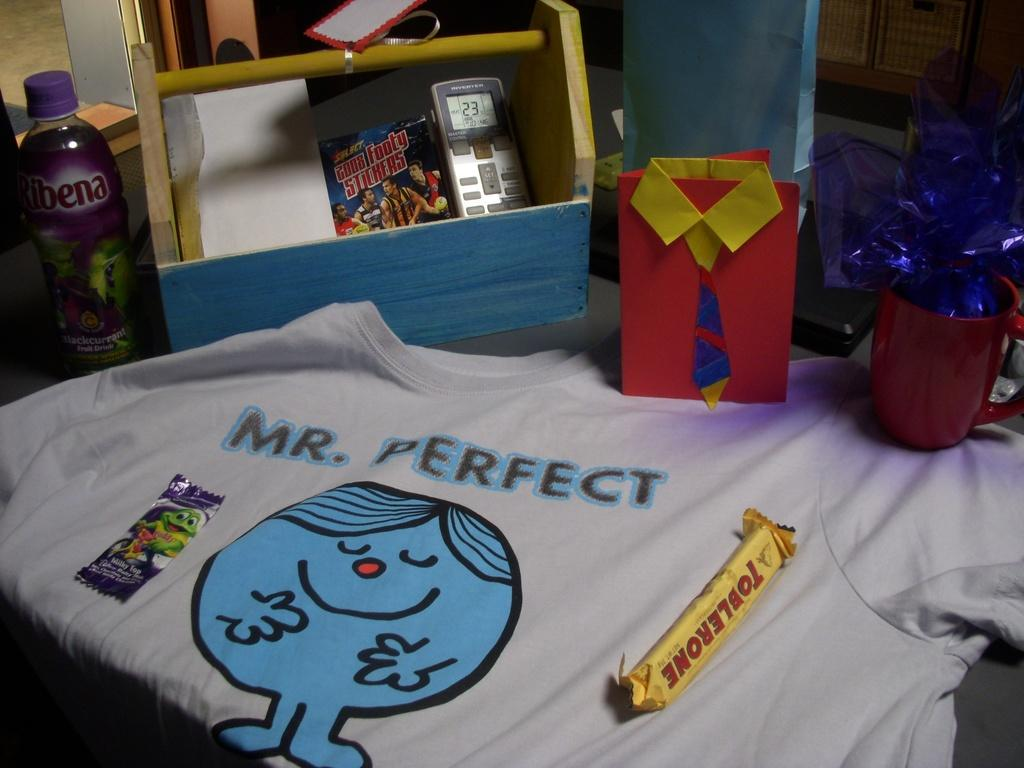<image>
Present a compact description of the photo's key features. Mrs. Perfect is written on a shirt next to a Toblerone candy bar 